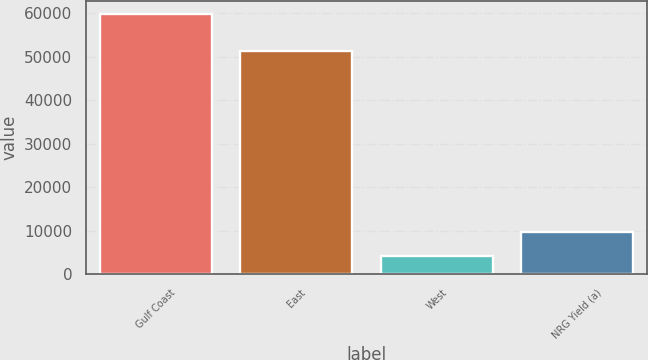Convert chart. <chart><loc_0><loc_0><loc_500><loc_500><bar_chart><fcel>Gulf Coast<fcel>East<fcel>West<fcel>NRG Yield (a)<nl><fcel>59871<fcel>51192<fcel>4241<fcel>9804<nl></chart> 